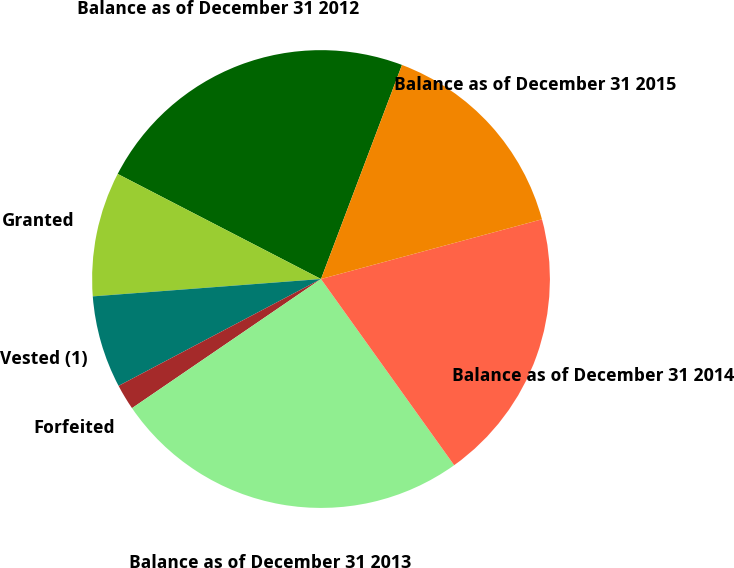Convert chart to OTSL. <chart><loc_0><loc_0><loc_500><loc_500><pie_chart><fcel>Balance as of December 31 2012<fcel>Granted<fcel>Vested (1)<fcel>Forfeited<fcel>Balance as of December 31 2013<fcel>Balance as of December 31 2014<fcel>Balance as of December 31 2015<nl><fcel>23.16%<fcel>8.8%<fcel>6.52%<fcel>1.81%<fcel>25.34%<fcel>19.32%<fcel>15.04%<nl></chart> 